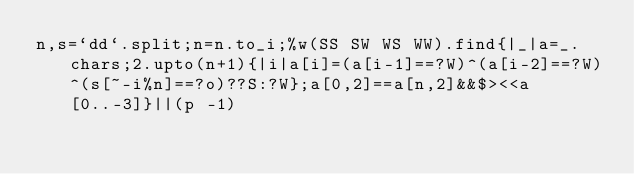<code> <loc_0><loc_0><loc_500><loc_500><_Ruby_>n,s=`dd`.split;n=n.to_i;%w(SS SW WS WW).find{|_|a=_.chars;2.upto(n+1){|i|a[i]=(a[i-1]==?W)^(a[i-2]==?W)^(s[~-i%n]==?o)??S:?W};a[0,2]==a[n,2]&&$><<a[0..-3]}||(p -1)</code> 